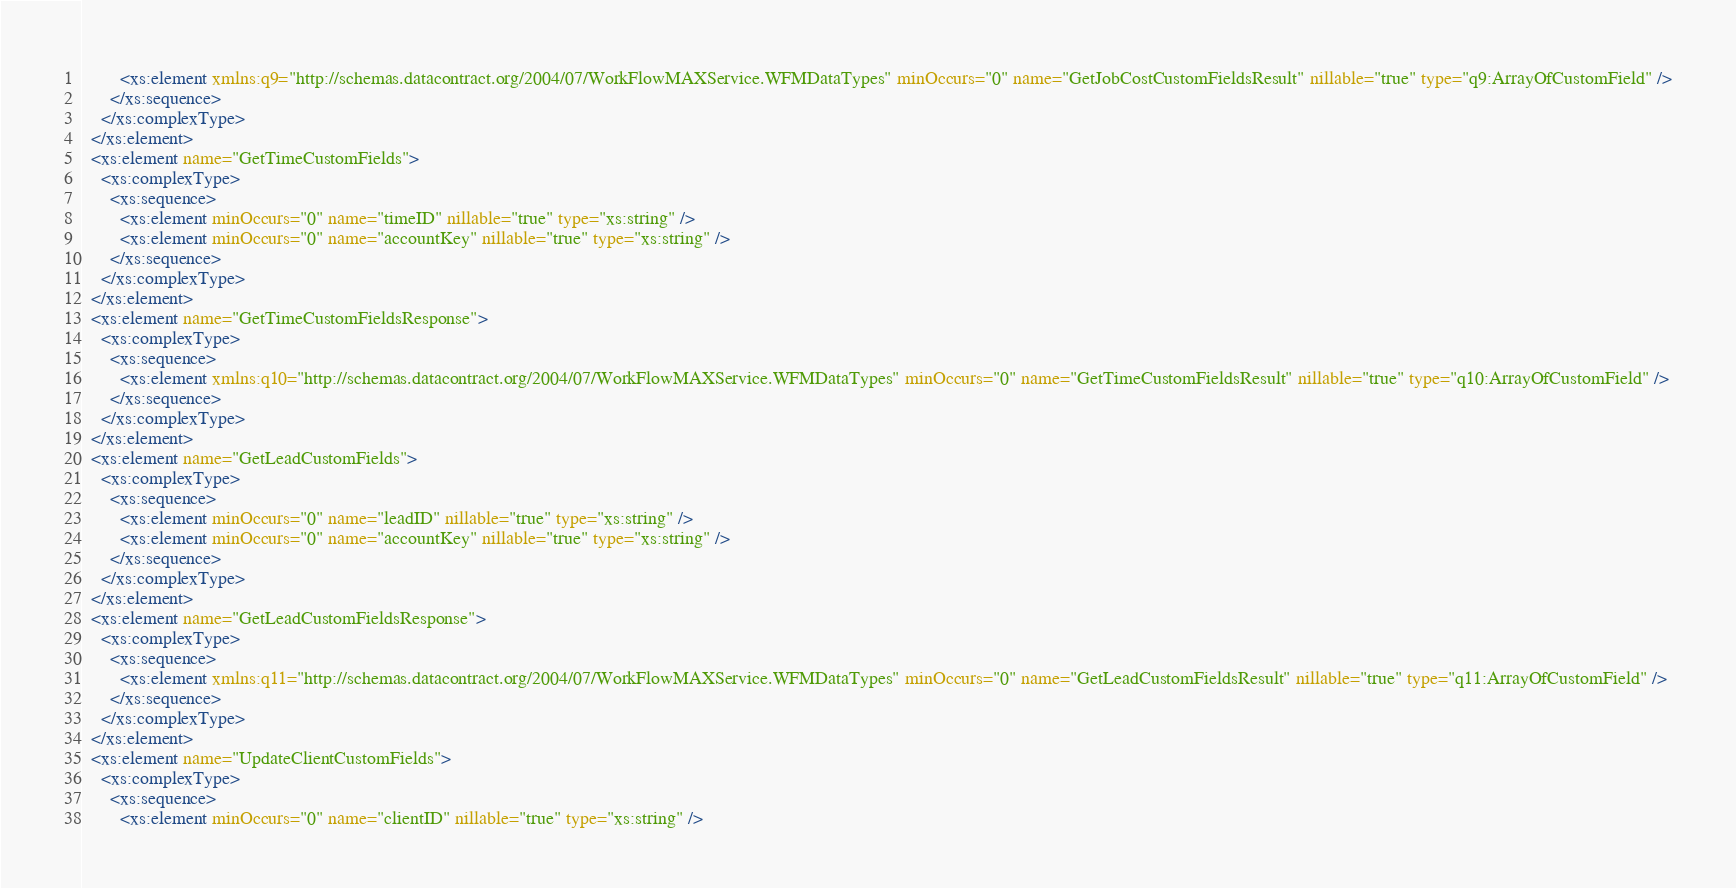<code> <loc_0><loc_0><loc_500><loc_500><_XML_>        <xs:element xmlns:q9="http://schemas.datacontract.org/2004/07/WorkFlowMAXService.WFMDataTypes" minOccurs="0" name="GetJobCostCustomFieldsResult" nillable="true" type="q9:ArrayOfCustomField" />
      </xs:sequence>
    </xs:complexType>
  </xs:element>
  <xs:element name="GetTimeCustomFields">
    <xs:complexType>
      <xs:sequence>
        <xs:element minOccurs="0" name="timeID" nillable="true" type="xs:string" />
        <xs:element minOccurs="0" name="accountKey" nillable="true" type="xs:string" />
      </xs:sequence>
    </xs:complexType>
  </xs:element>
  <xs:element name="GetTimeCustomFieldsResponse">
    <xs:complexType>
      <xs:sequence>
        <xs:element xmlns:q10="http://schemas.datacontract.org/2004/07/WorkFlowMAXService.WFMDataTypes" minOccurs="0" name="GetTimeCustomFieldsResult" nillable="true" type="q10:ArrayOfCustomField" />
      </xs:sequence>
    </xs:complexType>
  </xs:element>
  <xs:element name="GetLeadCustomFields">
    <xs:complexType>
      <xs:sequence>
        <xs:element minOccurs="0" name="leadID" nillable="true" type="xs:string" />
        <xs:element minOccurs="0" name="accountKey" nillable="true" type="xs:string" />
      </xs:sequence>
    </xs:complexType>
  </xs:element>
  <xs:element name="GetLeadCustomFieldsResponse">
    <xs:complexType>
      <xs:sequence>
        <xs:element xmlns:q11="http://schemas.datacontract.org/2004/07/WorkFlowMAXService.WFMDataTypes" minOccurs="0" name="GetLeadCustomFieldsResult" nillable="true" type="q11:ArrayOfCustomField" />
      </xs:sequence>
    </xs:complexType>
  </xs:element>
  <xs:element name="UpdateClientCustomFields">
    <xs:complexType>
      <xs:sequence>
        <xs:element minOccurs="0" name="clientID" nillable="true" type="xs:string" /></code> 